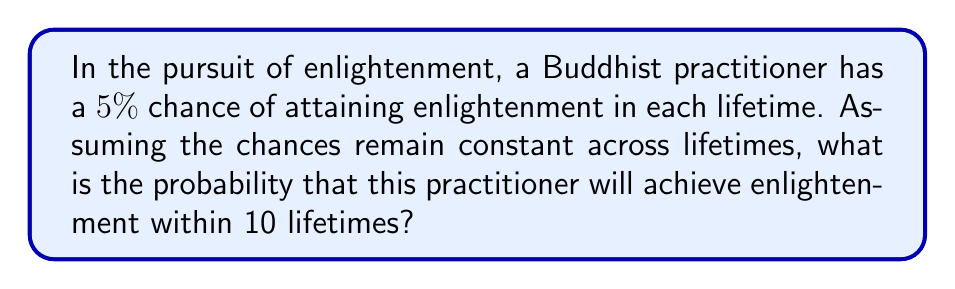Provide a solution to this math problem. To solve this problem, we need to approach it from the perspective of complementary events. Instead of calculating the probability of attaining enlightenment within 10 lifetimes directly, we can calculate the probability of not attaining enlightenment in 10 lifetimes and then subtract that from 1.

Let's break it down step-by-step:

1) The probability of attaining enlightenment in a single lifetime is 5% or 0.05.

2) Therefore, the probability of not attaining enlightenment in a single lifetime is:
   $1 - 0.05 = 0.95$ or 95%

3) For the practitioner to not attain enlightenment in 10 lifetimes, they must fail to attain it in each of the 10 lifetimes. Since the events are independent, we multiply these probabilities:

   $$(0.95)^{10}$$

4) This gives us the probability of not attaining enlightenment in 10 lifetimes.

5) To find the probability of attaining enlightenment within 10 lifetimes, we subtract this from 1:

   $$1 - (0.95)^{10}$$

6) Let's calculate this:
   $$(0.95)^{10} \approx 0.5987$$
   
   $$1 - 0.5987 \approx 0.4013$$

7) Convert to a percentage:
   $$0.4013 * 100\% \approx 40.13\%$$

Therefore, the probability of attaining enlightenment within 10 lifetimes is approximately 40.13%.
Answer: The probability of attaining enlightenment within 10 lifetimes is approximately 40.13%. 